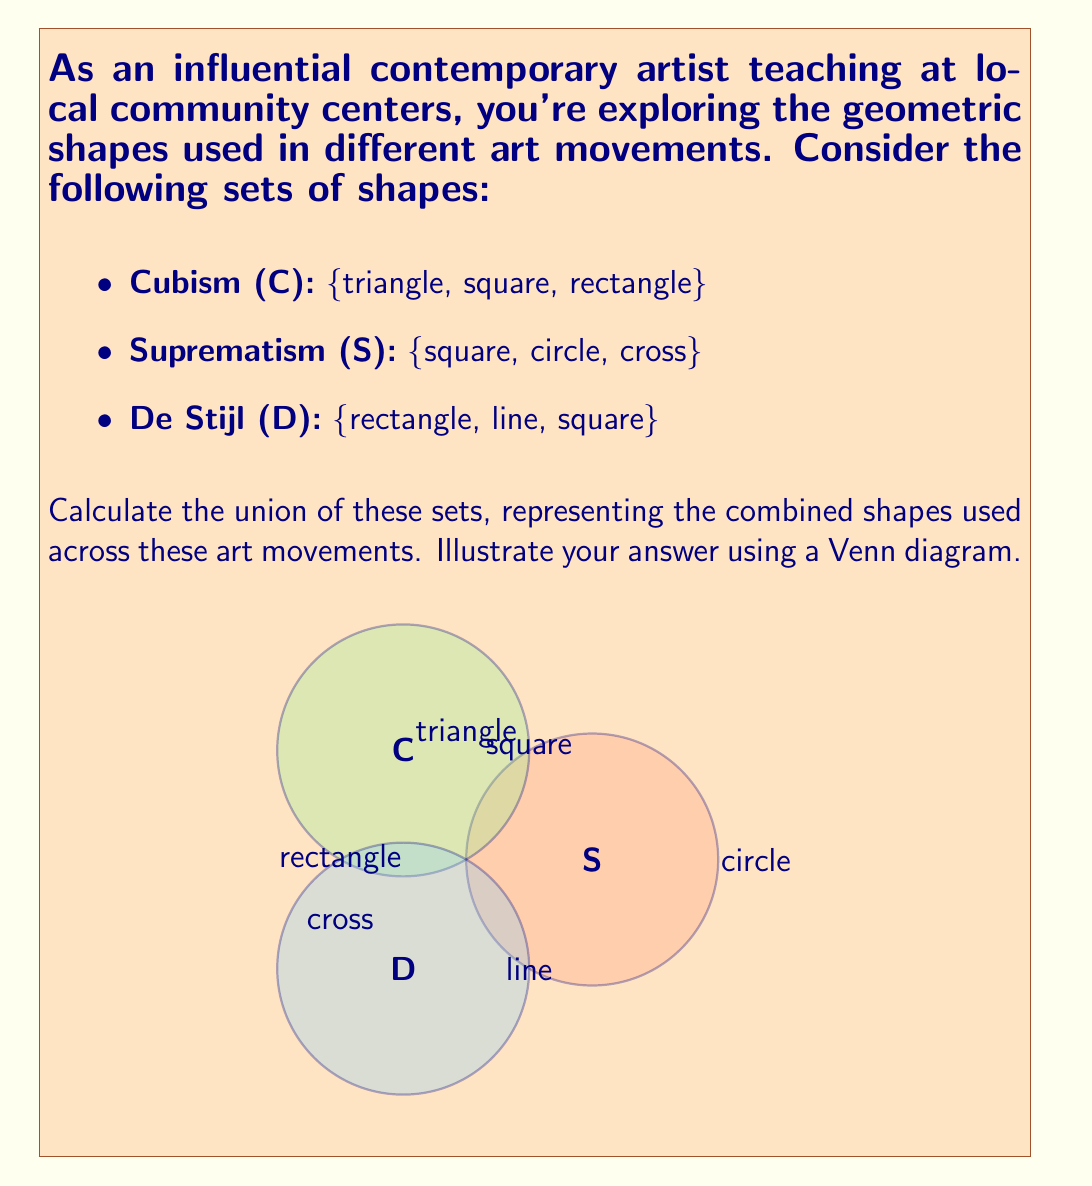Provide a solution to this math problem. To calculate the union of these sets, we need to combine all unique elements from each set. Let's approach this step-by-step:

1) First, let's list out the elements of each set:
   C = {triangle, square, rectangle}
   S = {square, circle, cross}
   D = {rectangle, line, square}

2) The union of these sets, denoted as $C \cup S \cup D$, will include all unique elements from all sets.

3) Let's start with C and add unique elements from S and D:
   - From C: triangle, square, rectangle
   - From S: circle, cross (square is already included)
   - From D: line (rectangle and square are already included)

4) Therefore, the union of these sets is:
   $C \cup S \cup D = \{triangle, square, rectangle, circle, cross, line\}$

5) The Venn diagram in the question illustrates this union visually:
   - The overlapping region of all three circles contains "square"
   - The overlap between C and D contains "rectangle"
   - The remaining elements are unique to their respective sets

This union represents the combined set of geometric shapes used across Cubism, Suprematism, and De Stijl movements.
Answer: $\{triangle, square, rectangle, circle, cross, line\}$ 